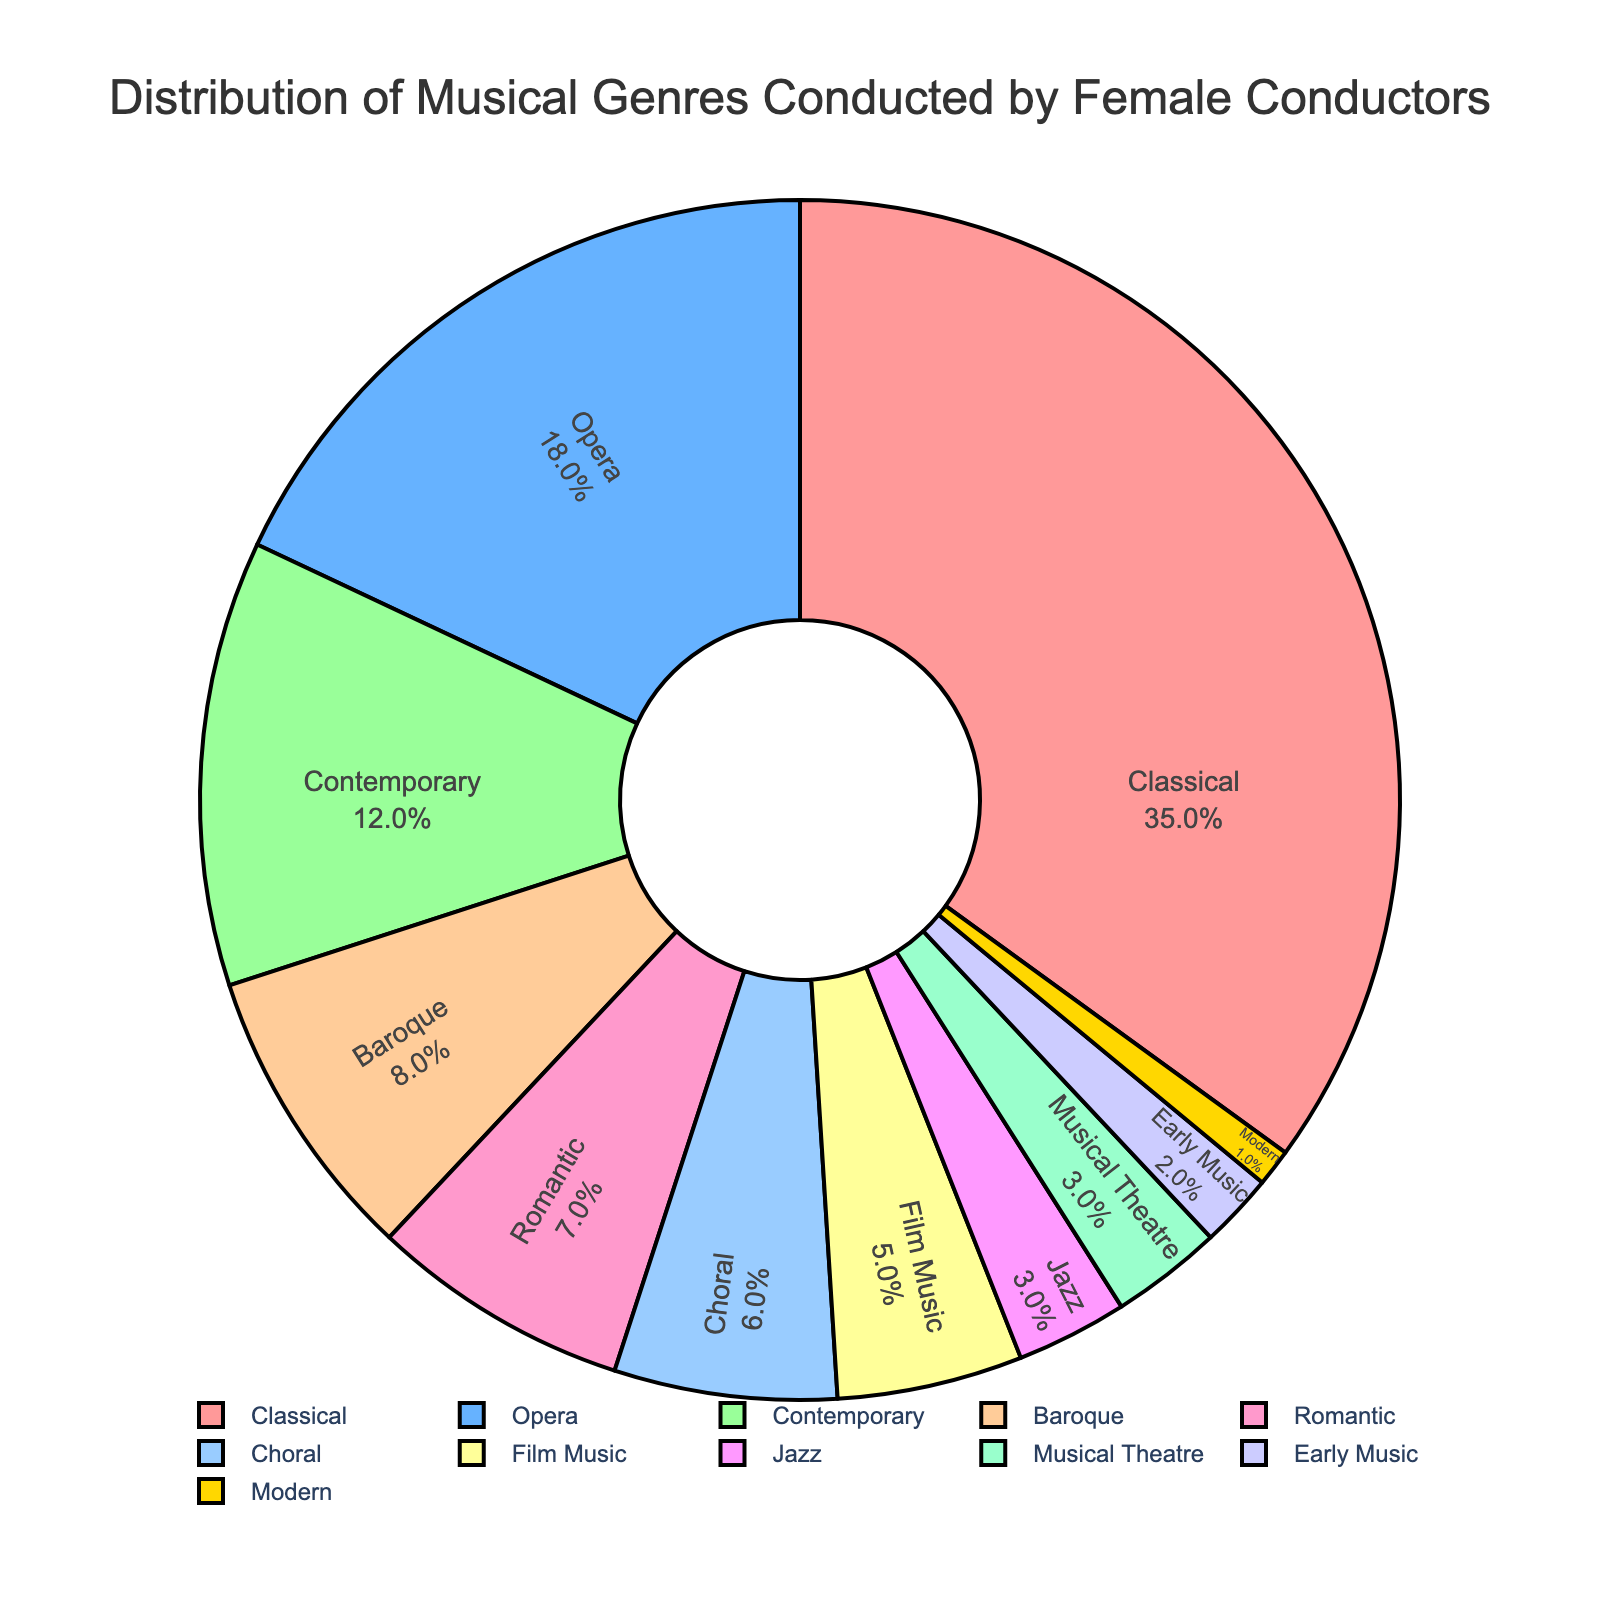Which musical genre has the highest percentage of female conductors? The pie chart illustrates that the "Classical" genre occupies the largest portion of the pie, indicating it has the highest percentage.
Answer: Classical What is the combined percentage of female conductors in Romantic and Baroque genres? The percentages for Romantic and Baroque genres are 7% and 8%, respectively. Summing these gives 7 + 8 = 15%.
Answer: 15% How many more percentage points does Classical have compared to Contemporary? Classical has 35%, and Contemporary has 12%. Subtracting these gives 35 - 12 = 23%.
Answer: 23% Between Opera and Jazz, which genre has a higher percentage of female conductors and by how much? Opera has 18%, and Jazz has 3%. The difference is 18 - 3 = 15%.
Answer: Opera, by 15% What is the third most represented genre by female conductors? The Classical genre has the highest percentage, followed by Opera. The third-highest percentage is Contemporary with 12%.
Answer: Contemporary What percentage of female conductors are involved in genres with less than 5% representation each? The genres with less than 5% are Jazz (3%), Musical Theatre (3%), Early Music (2%), Modern (1%). Summing these gives 3 + 3 + 2 + 1 = 9%.
Answer: 9% Are there more female conductors in Choral or Film Music genres? Comparing the percentages, Choral has 6%, and Film Music has 5%. Thus, there are more in Choral.
Answer: Choral If you combine the percentages of Baroque, Early Music, and Modern genres, what total do you get? Adding Baroque (8%), Early Music (2%), and Modern (1%) yields 8 + 2 + 1 = 11%.
Answer: 11% Rank the top four genres by the percentage of female conductors. The top four percentages are Classical (35%), Opera (18%), Contemporary (12%), Baroque (8%).
Answer: Classical, Opera, Contemporary, Baroque What visual characteristic indicates that a genre has a larger percentage of female conductors? In the pie chart, larger sections or slices represent higher percentages.
Answer: Larger sections 